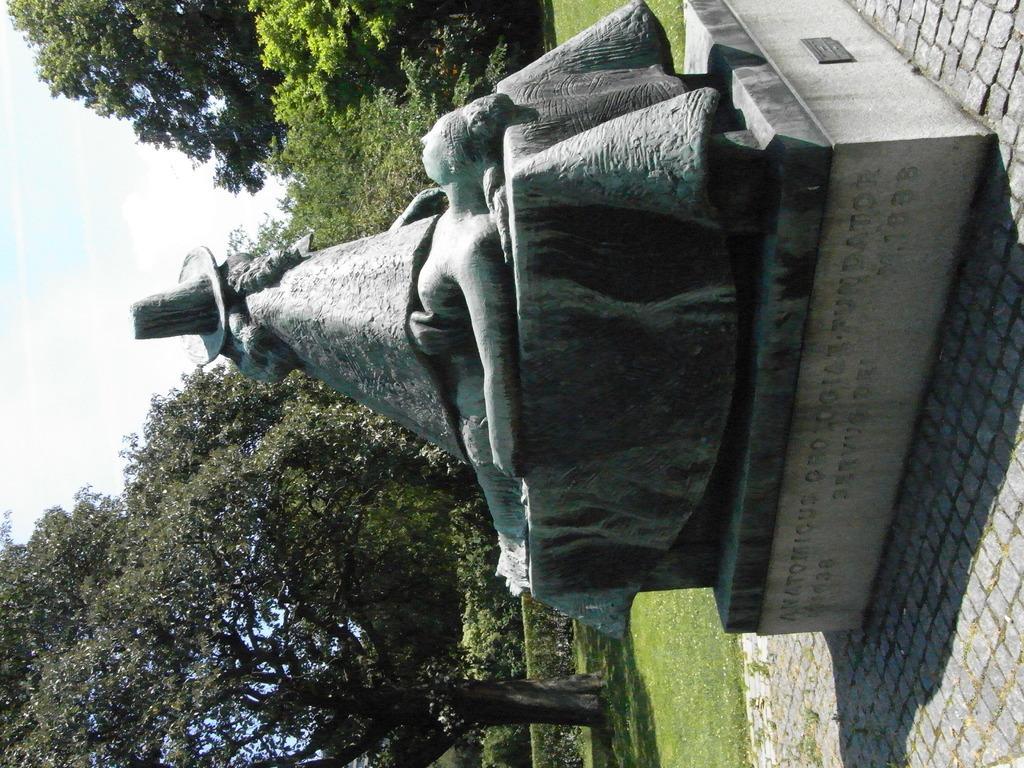Could you give a brief overview of what you see in this image? This is an outside view and this image is in left direction. Here I can see a statue of a person on the pillar. In the background, I can see the grass and trees. On the left side, I can see the sky. 